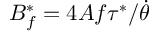Convert formula to latex. <formula><loc_0><loc_0><loc_500><loc_500>B _ { f } ^ { * } = 4 A f \tau ^ { * } / \dot { \theta }</formula> 